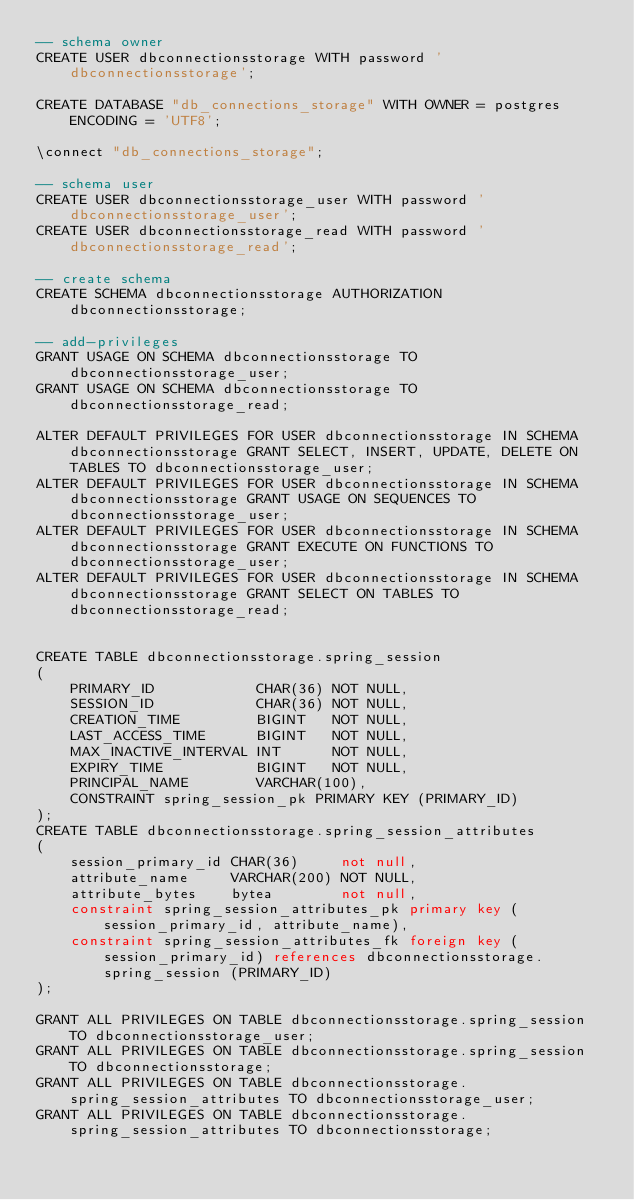Convert code to text. <code><loc_0><loc_0><loc_500><loc_500><_SQL_>-- schema owner
CREATE USER dbconnectionsstorage WITH password 'dbconnectionsstorage';

CREATE DATABASE "db_connections_storage" WITH OWNER = postgres ENCODING = 'UTF8';

\connect "db_connections_storage";

-- schema user
CREATE USER dbconnectionsstorage_user WITH password 'dbconnectionsstorage_user';
CREATE USER dbconnectionsstorage_read WITH password 'dbconnectionsstorage_read';

-- create schema
CREATE SCHEMA dbconnectionsstorage AUTHORIZATION dbconnectionsstorage;

-- add-privileges
GRANT USAGE ON SCHEMA dbconnectionsstorage TO dbconnectionsstorage_user;
GRANT USAGE ON SCHEMA dbconnectionsstorage TO dbconnectionsstorage_read;

ALTER DEFAULT PRIVILEGES FOR USER dbconnectionsstorage IN SCHEMA dbconnectionsstorage GRANT SELECT, INSERT, UPDATE, DELETE ON TABLES TO dbconnectionsstorage_user;
ALTER DEFAULT PRIVILEGES FOR USER dbconnectionsstorage IN SCHEMA dbconnectionsstorage GRANT USAGE ON SEQUENCES TO dbconnectionsstorage_user;
ALTER DEFAULT PRIVILEGES FOR USER dbconnectionsstorage IN SCHEMA dbconnectionsstorage GRANT EXECUTE ON FUNCTIONS TO dbconnectionsstorage_user;
ALTER DEFAULT PRIVILEGES FOR USER dbconnectionsstorage IN SCHEMA dbconnectionsstorage GRANT SELECT ON TABLES TO dbconnectionsstorage_read;


CREATE TABLE dbconnectionsstorage.spring_session
(
    PRIMARY_ID            CHAR(36) NOT NULL,
    SESSION_ID            CHAR(36) NOT NULL,
    CREATION_TIME         BIGINT   NOT NULL,
    LAST_ACCESS_TIME      BIGINT   NOT NULL,
    MAX_INACTIVE_INTERVAL INT      NOT NULL,
    EXPIRY_TIME           BIGINT   NOT NULL,
    PRINCIPAL_NAME        VARCHAR(100),
    CONSTRAINT spring_session_pk PRIMARY KEY (PRIMARY_ID)
);
CREATE TABLE dbconnectionsstorage.spring_session_attributes
(
    session_primary_id CHAR(36)     not null,
    attribute_name     VARCHAR(200) NOT NULL,
    attribute_bytes    bytea        not null,
    constraint spring_session_attributes_pk primary key (session_primary_id, attribute_name),
    constraint spring_session_attributes_fk foreign key (session_primary_id) references dbconnectionsstorage.spring_session (PRIMARY_ID)
);

GRANT ALL PRIVILEGES ON TABLE dbconnectionsstorage.spring_session TO dbconnectionsstorage_user;
GRANT ALL PRIVILEGES ON TABLE dbconnectionsstorage.spring_session TO dbconnectionsstorage;
GRANT ALL PRIVILEGES ON TABLE dbconnectionsstorage.spring_session_attributes TO dbconnectionsstorage_user;
GRANT ALL PRIVILEGES ON TABLE dbconnectionsstorage.spring_session_attributes TO dbconnectionsstorage;
</code> 